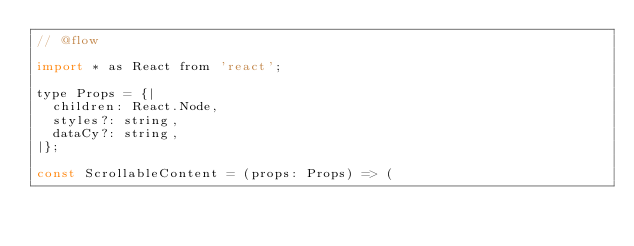<code> <loc_0><loc_0><loc_500><loc_500><_JavaScript_>// @flow

import * as React from 'react';

type Props = {|
  children: React.Node,
  styles?: string,
  dataCy?: string,
|};

const ScrollableContent = (props: Props) => (</code> 